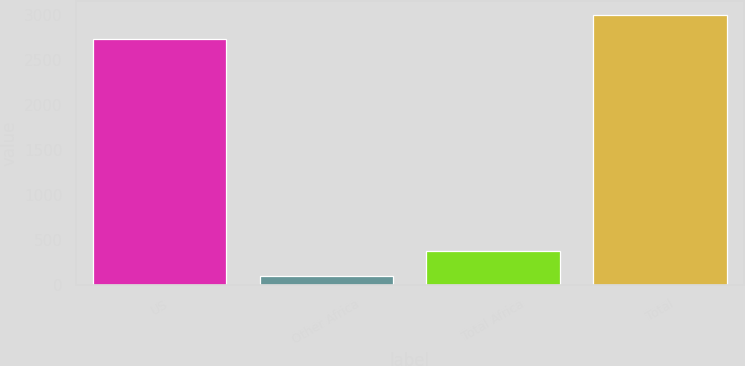Convert chart. <chart><loc_0><loc_0><loc_500><loc_500><bar_chart><fcel>US<fcel>Other Africa<fcel>Total Africa<fcel>Total<nl><fcel>2727<fcel>94<fcel>369.3<fcel>3002.3<nl></chart> 